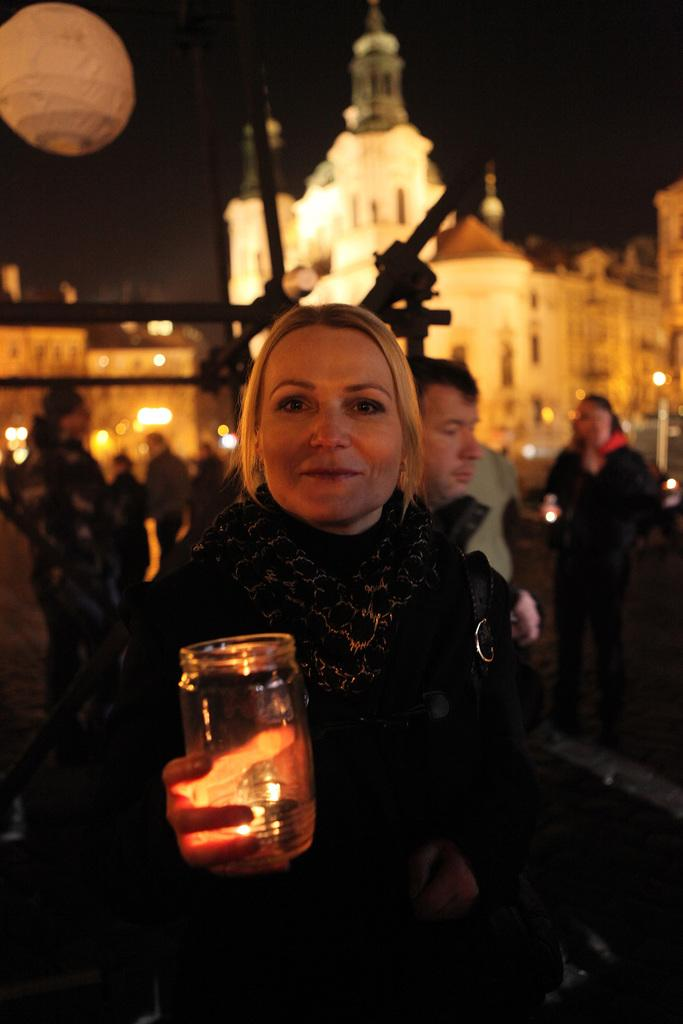Who is the main subject in the foreground of the image? There is a woman in the foreground of the image. What is the woman holding in her hand? The woman is holding a glass bowl in her hand. What can be seen in the background of the image? There are buildings and people in the background of the image. Where is the faucet located in the image? There is no faucet present in the image. What type of bead is being used as a decoration in the image? There is no bead present in the image. 